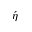Convert formula to latex. <formula><loc_0><loc_0><loc_500><loc_500>\acute { \eta }</formula> 